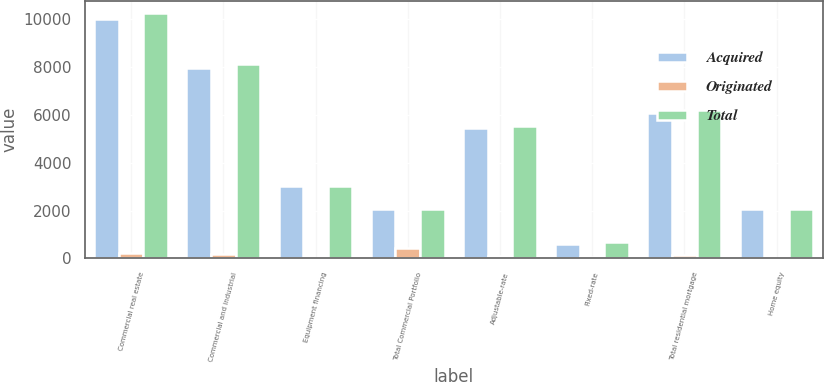Convert chart to OTSL. <chart><loc_0><loc_0><loc_500><loc_500><stacked_bar_chart><ecel><fcel>Commercial real estate<fcel>Commercial and industrial<fcel>Equipment financing<fcel>Total Commercial Portfolio<fcel>Adjustable-rate<fcel>Fixed-rate<fcel>Total residential mortgage<fcel>Home equity<nl><fcel>Acquired<fcel>10012.6<fcel>7939<fcel>3020.9<fcel>2058.75<fcel>5453.8<fcel>613.5<fcel>6067.3<fcel>2044.9<nl><fcel>Originated<fcel>234.7<fcel>186.1<fcel>11.6<fcel>432.4<fcel>95.3<fcel>54.1<fcel>149.4<fcel>27.7<nl><fcel>Total<fcel>10247.3<fcel>8125.1<fcel>3032.5<fcel>2058.75<fcel>5549.1<fcel>667.6<fcel>6216.7<fcel>2072.6<nl></chart> 